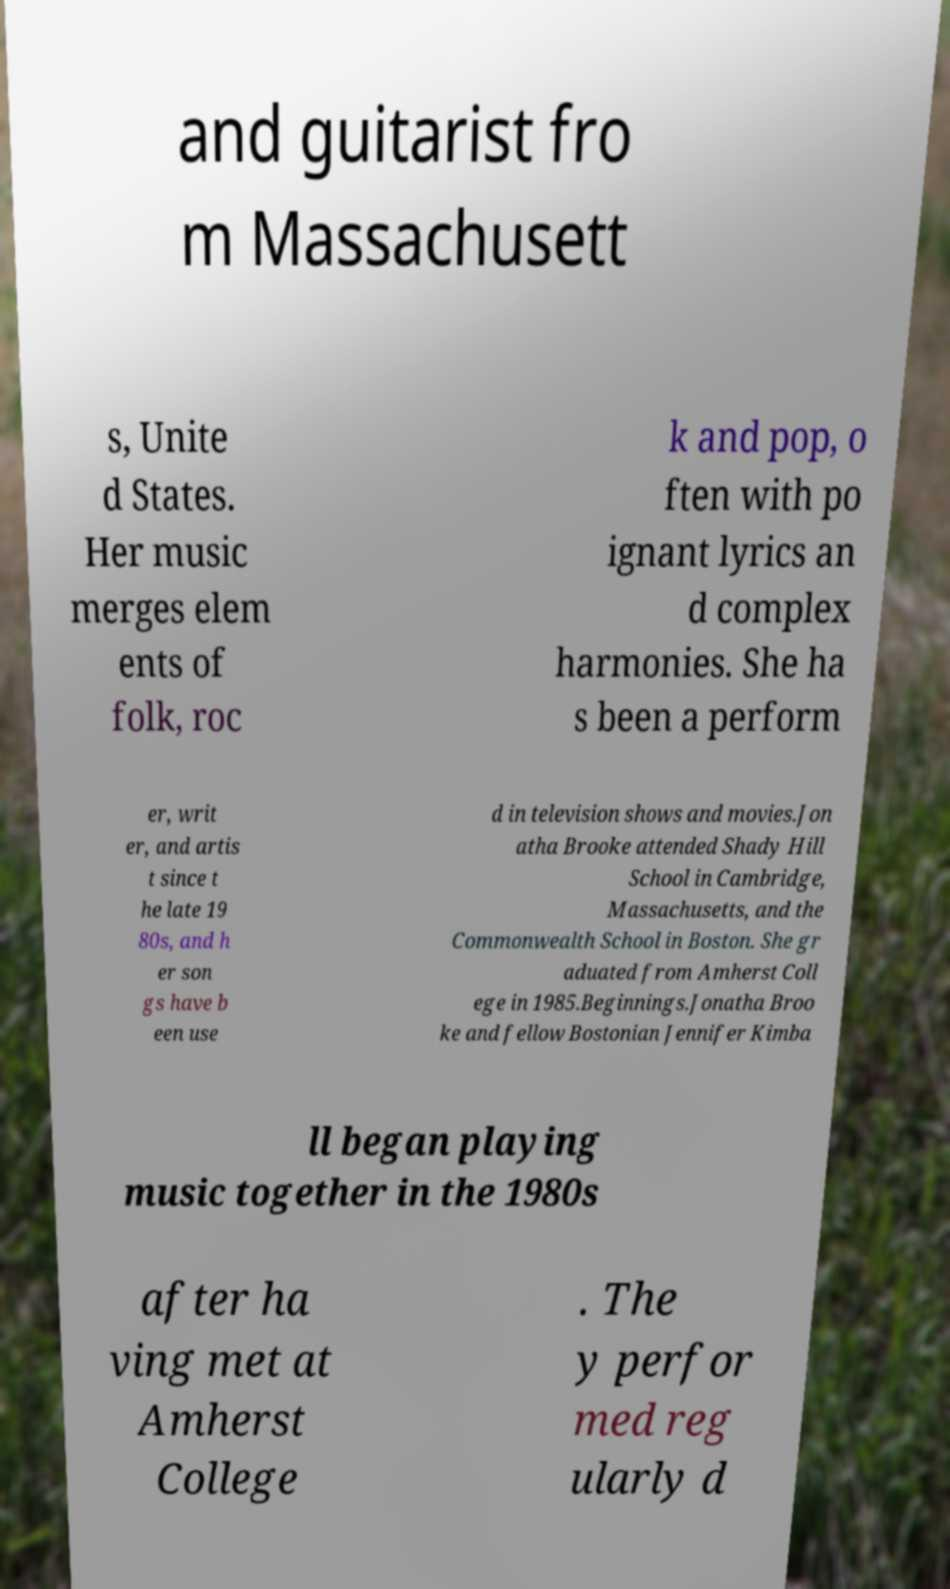Could you extract and type out the text from this image? and guitarist fro m Massachusett s, Unite d States. Her music merges elem ents of folk, roc k and pop, o ften with po ignant lyrics an d complex harmonies. She ha s been a perform er, writ er, and artis t since t he late 19 80s, and h er son gs have b een use d in television shows and movies.Jon atha Brooke attended Shady Hill School in Cambridge, Massachusetts, and the Commonwealth School in Boston. She gr aduated from Amherst Coll ege in 1985.Beginnings.Jonatha Broo ke and fellow Bostonian Jennifer Kimba ll began playing music together in the 1980s after ha ving met at Amherst College . The y perfor med reg ularly d 